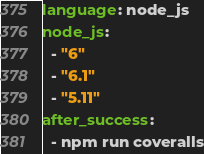<code> <loc_0><loc_0><loc_500><loc_500><_YAML_>language: node_js
node_js:
  - "6"
  - "6.1"
  - "5.11"
after_success:
  - npm run coveralls
</code> 